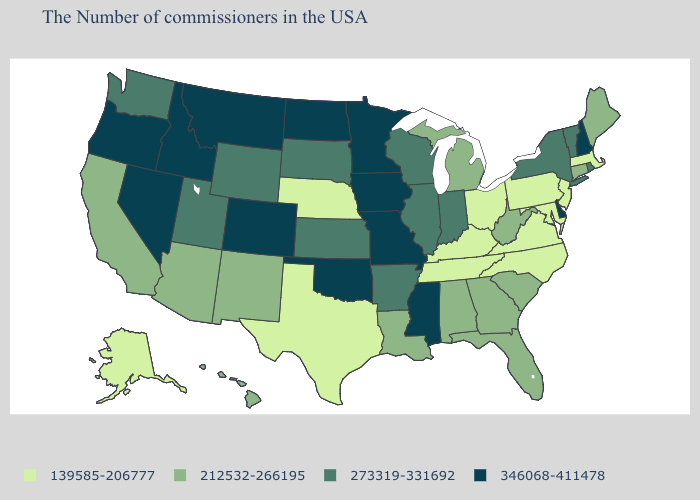What is the highest value in the South ?
Answer briefly. 346068-411478. Name the states that have a value in the range 346068-411478?
Concise answer only. New Hampshire, Delaware, Mississippi, Missouri, Minnesota, Iowa, Oklahoma, North Dakota, Colorado, Montana, Idaho, Nevada, Oregon. What is the value of New Jersey?
Concise answer only. 139585-206777. Name the states that have a value in the range 139585-206777?
Short answer required. Massachusetts, New Jersey, Maryland, Pennsylvania, Virginia, North Carolina, Ohio, Kentucky, Tennessee, Nebraska, Texas, Alaska. Does New Mexico have the highest value in the West?
Be succinct. No. Does Illinois have the same value as New Hampshire?
Be succinct. No. Does Idaho have a lower value than Nevada?
Answer briefly. No. What is the lowest value in the West?
Keep it brief. 139585-206777. Name the states that have a value in the range 346068-411478?
Be succinct. New Hampshire, Delaware, Mississippi, Missouri, Minnesota, Iowa, Oklahoma, North Dakota, Colorado, Montana, Idaho, Nevada, Oregon. What is the value of Mississippi?
Give a very brief answer. 346068-411478. What is the highest value in the USA?
Concise answer only. 346068-411478. What is the value of Indiana?
Concise answer only. 273319-331692. Name the states that have a value in the range 273319-331692?
Give a very brief answer. Rhode Island, Vermont, New York, Indiana, Wisconsin, Illinois, Arkansas, Kansas, South Dakota, Wyoming, Utah, Washington. What is the value of Alaska?
Answer briefly. 139585-206777. Does Iowa have the highest value in the MidWest?
Give a very brief answer. Yes. 